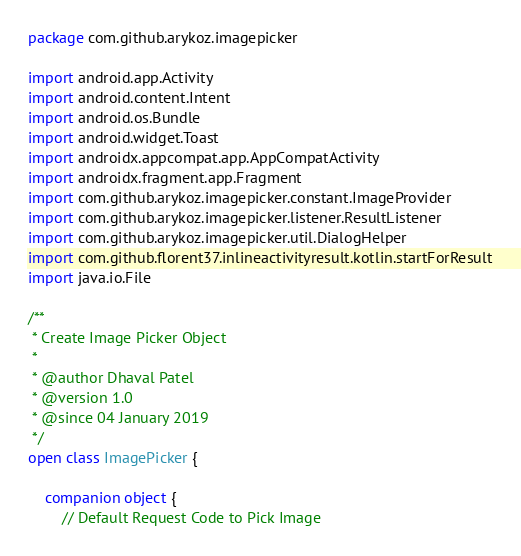Convert code to text. <code><loc_0><loc_0><loc_500><loc_500><_Kotlin_>package com.github.arykoz.imagepicker

import android.app.Activity
import android.content.Intent
import android.os.Bundle
import android.widget.Toast
import androidx.appcompat.app.AppCompatActivity
import androidx.fragment.app.Fragment
import com.github.arykoz.imagepicker.constant.ImageProvider
import com.github.arykoz.imagepicker.listener.ResultListener
import com.github.arykoz.imagepicker.util.DialogHelper
import com.github.florent37.inlineactivityresult.kotlin.startForResult
import java.io.File

/**
 * Create Image Picker Object
 *
 * @author Dhaval Patel
 * @version 1.0
 * @since 04 January 2019
 */
open class ImagePicker {

    companion object {
        // Default Request Code to Pick Image</code> 